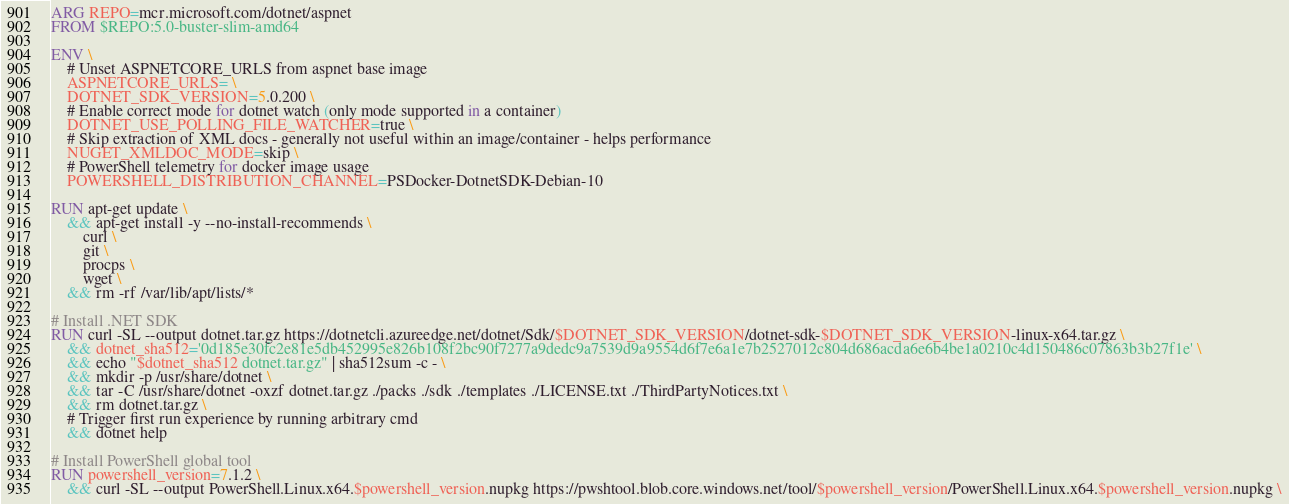<code> <loc_0><loc_0><loc_500><loc_500><_Dockerfile_>ARG REPO=mcr.microsoft.com/dotnet/aspnet
FROM $REPO:5.0-buster-slim-amd64

ENV \
    # Unset ASPNETCORE_URLS from aspnet base image
    ASPNETCORE_URLS= \
    DOTNET_SDK_VERSION=5.0.200 \
    # Enable correct mode for dotnet watch (only mode supported in a container)
    DOTNET_USE_POLLING_FILE_WATCHER=true \
    # Skip extraction of XML docs - generally not useful within an image/container - helps performance
    NUGET_XMLDOC_MODE=skip \
    # PowerShell telemetry for docker image usage
    POWERSHELL_DISTRIBUTION_CHANNEL=PSDocker-DotnetSDK-Debian-10

RUN apt-get update \
    && apt-get install -y --no-install-recommends \
        curl \
        git \
        procps \
        wget \
    && rm -rf /var/lib/apt/lists/*

# Install .NET SDK
RUN curl -SL --output dotnet.tar.gz https://dotnetcli.azureedge.net/dotnet/Sdk/$DOTNET_SDK_VERSION/dotnet-sdk-$DOTNET_SDK_VERSION-linux-x64.tar.gz \
    && dotnet_sha512='0d185e30fc2e81e5db452995e826b108f2bc90f7277a9dedc9a7539d9a9554d6f7e6a1e7b2527012c804d686acda6e6b4be1a0210c4d150486c07863b3b27f1e' \
    && echo "$dotnet_sha512 dotnet.tar.gz" | sha512sum -c - \
    && mkdir -p /usr/share/dotnet \
    && tar -C /usr/share/dotnet -oxzf dotnet.tar.gz ./packs ./sdk ./templates ./LICENSE.txt ./ThirdPartyNotices.txt \
    && rm dotnet.tar.gz \
    # Trigger first run experience by running arbitrary cmd
    && dotnet help

# Install PowerShell global tool
RUN powershell_version=7.1.2 \
    && curl -SL --output PowerShell.Linux.x64.$powershell_version.nupkg https://pwshtool.blob.core.windows.net/tool/$powershell_version/PowerShell.Linux.x64.$powershell_version.nupkg \</code> 